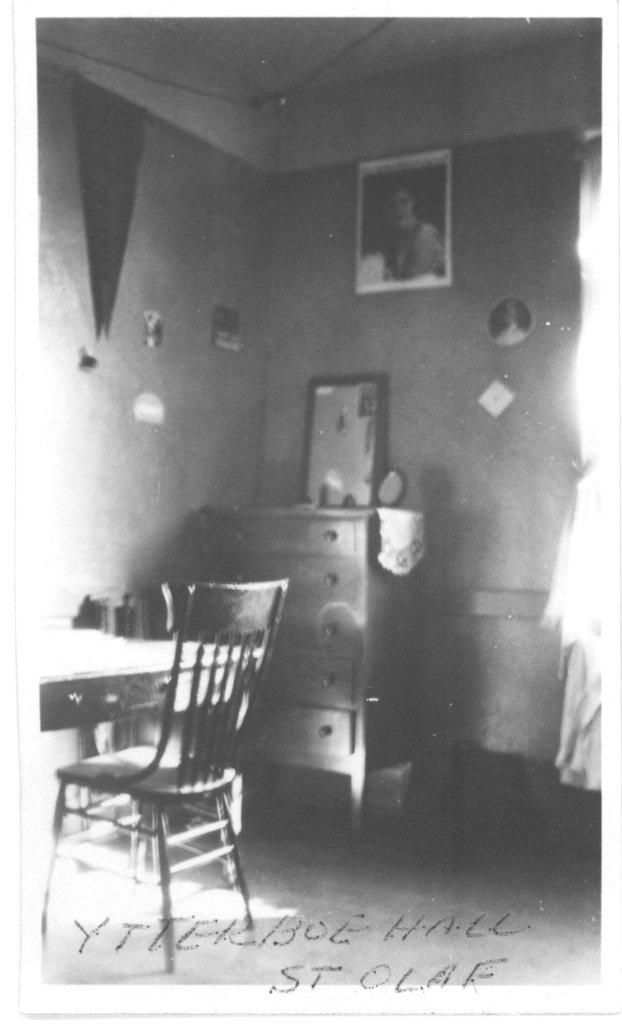What is the color scheme of the image? The image is black and white. What type of furniture can be seen in the image? There is a chair, a table, and a cupboard in the image. What type of structure is present in the image? There is a wall in the image. What type of decorative item is present in the image? There is a frame in the image. How many rabbits are hopping on the table in the image? There are no rabbits present in the image; it only features a chair, table, cupboard, wall, and frame. 